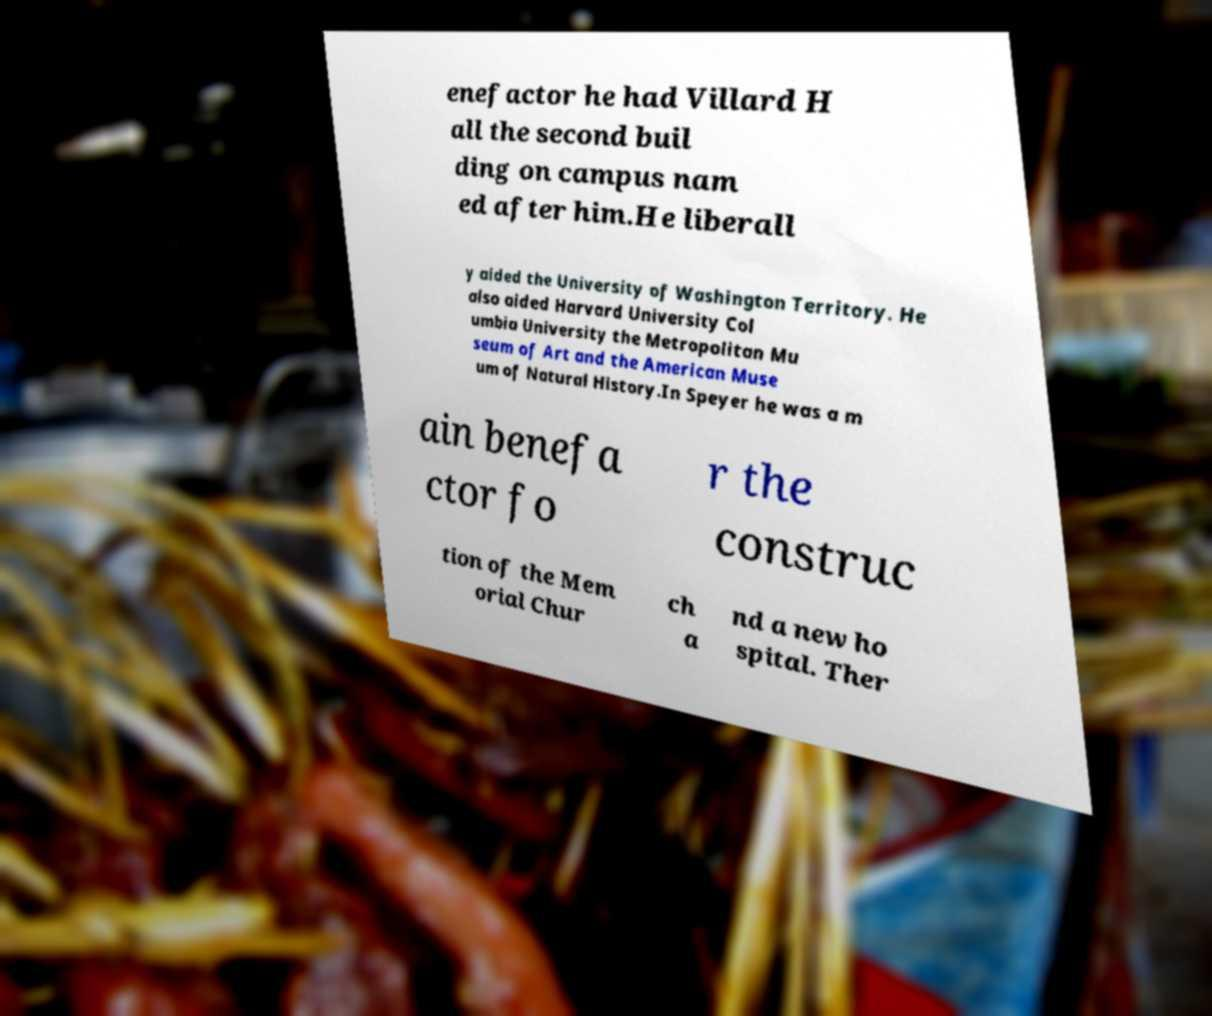What messages or text are displayed in this image? I need them in a readable, typed format. enefactor he had Villard H all the second buil ding on campus nam ed after him.He liberall y aided the University of Washington Territory. He also aided Harvard University Col umbia University the Metropolitan Mu seum of Art and the American Muse um of Natural History.In Speyer he was a m ain benefa ctor fo r the construc tion of the Mem orial Chur ch a nd a new ho spital. Ther 